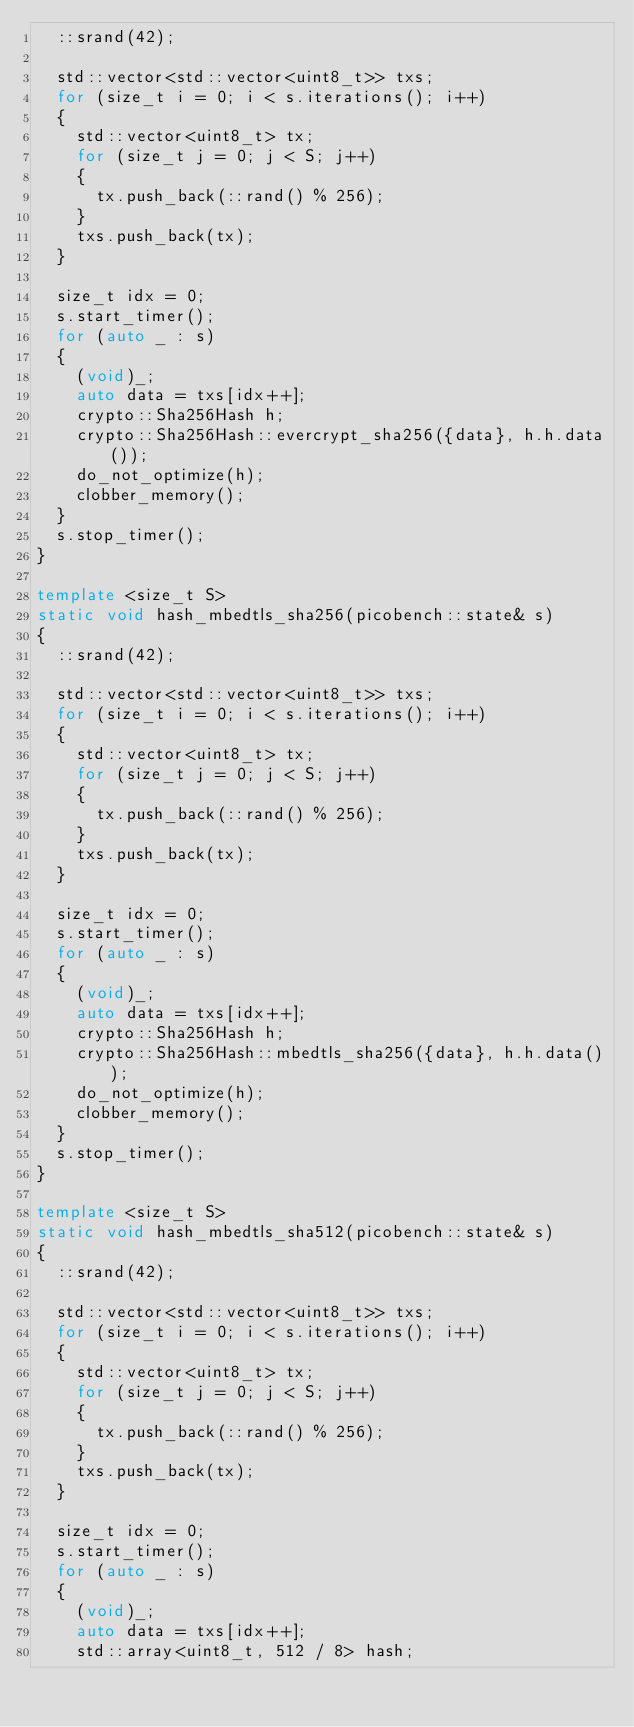Convert code to text. <code><loc_0><loc_0><loc_500><loc_500><_C++_>  ::srand(42);

  std::vector<std::vector<uint8_t>> txs;
  for (size_t i = 0; i < s.iterations(); i++)
  {
    std::vector<uint8_t> tx;
    for (size_t j = 0; j < S; j++)
    {
      tx.push_back(::rand() % 256);
    }
    txs.push_back(tx);
  }

  size_t idx = 0;
  s.start_timer();
  for (auto _ : s)
  {
    (void)_;
    auto data = txs[idx++];
    crypto::Sha256Hash h;
    crypto::Sha256Hash::evercrypt_sha256({data}, h.h.data());
    do_not_optimize(h);
    clobber_memory();
  }
  s.stop_timer();
}

template <size_t S>
static void hash_mbedtls_sha256(picobench::state& s)
{
  ::srand(42);

  std::vector<std::vector<uint8_t>> txs;
  for (size_t i = 0; i < s.iterations(); i++)
  {
    std::vector<uint8_t> tx;
    for (size_t j = 0; j < S; j++)
    {
      tx.push_back(::rand() % 256);
    }
    txs.push_back(tx);
  }

  size_t idx = 0;
  s.start_timer();
  for (auto _ : s)
  {
    (void)_;
    auto data = txs[idx++];
    crypto::Sha256Hash h;
    crypto::Sha256Hash::mbedtls_sha256({data}, h.h.data());
    do_not_optimize(h);
    clobber_memory();
  }
  s.stop_timer();
}

template <size_t S>
static void hash_mbedtls_sha512(picobench::state& s)
{
  ::srand(42);

  std::vector<std::vector<uint8_t>> txs;
  for (size_t i = 0; i < s.iterations(); i++)
  {
    std::vector<uint8_t> tx;
    for (size_t j = 0; j < S; j++)
    {
      tx.push_back(::rand() % 256);
    }
    txs.push_back(tx);
  }

  size_t idx = 0;
  s.start_timer();
  for (auto _ : s)
  {
    (void)_;
    auto data = txs[idx++];
    std::array<uint8_t, 512 / 8> hash;</code> 